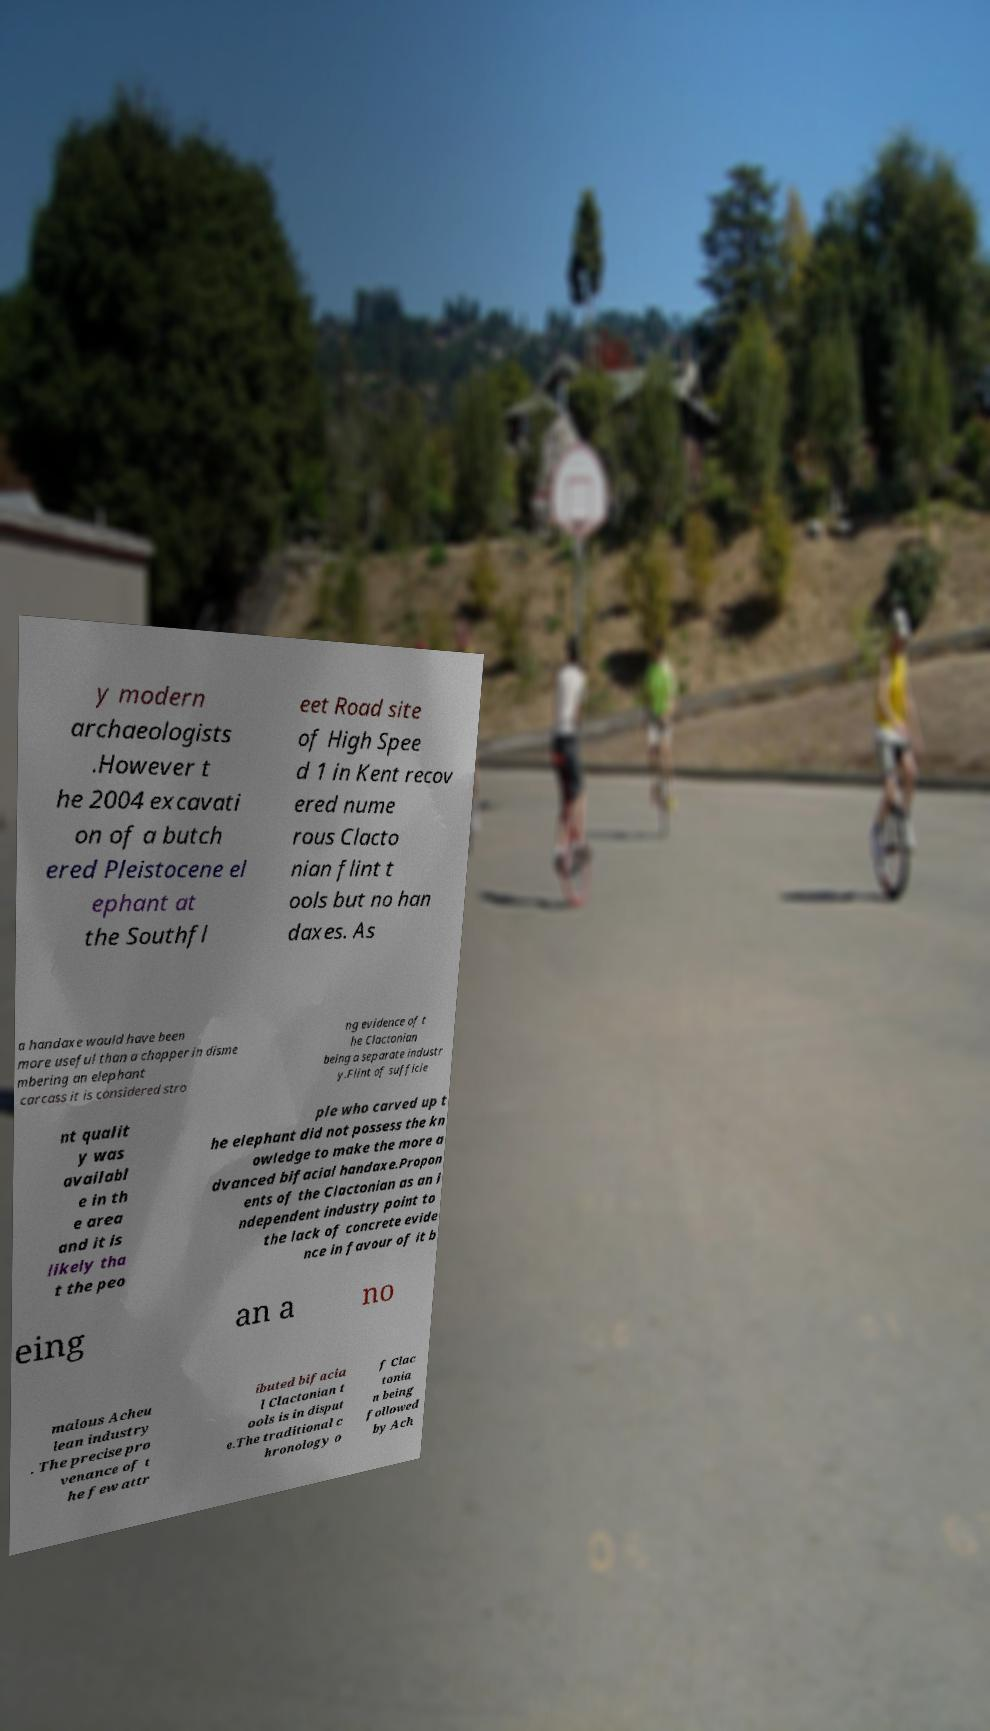I need the written content from this picture converted into text. Can you do that? y modern archaeologists .However t he 2004 excavati on of a butch ered Pleistocene el ephant at the Southfl eet Road site of High Spee d 1 in Kent recov ered nume rous Clacto nian flint t ools but no han daxes. As a handaxe would have been more useful than a chopper in disme mbering an elephant carcass it is considered stro ng evidence of t he Clactonian being a separate industr y.Flint of sufficie nt qualit y was availabl e in th e area and it is likely tha t the peo ple who carved up t he elephant did not possess the kn owledge to make the more a dvanced bifacial handaxe.Propon ents of the Clactonian as an i ndependent industry point to the lack of concrete evide nce in favour of it b eing an a no malous Acheu lean industry . The precise pro venance of t he few attr ibuted bifacia l Clactonian t ools is in disput e.The traditional c hronology o f Clac tonia n being followed by Ach 